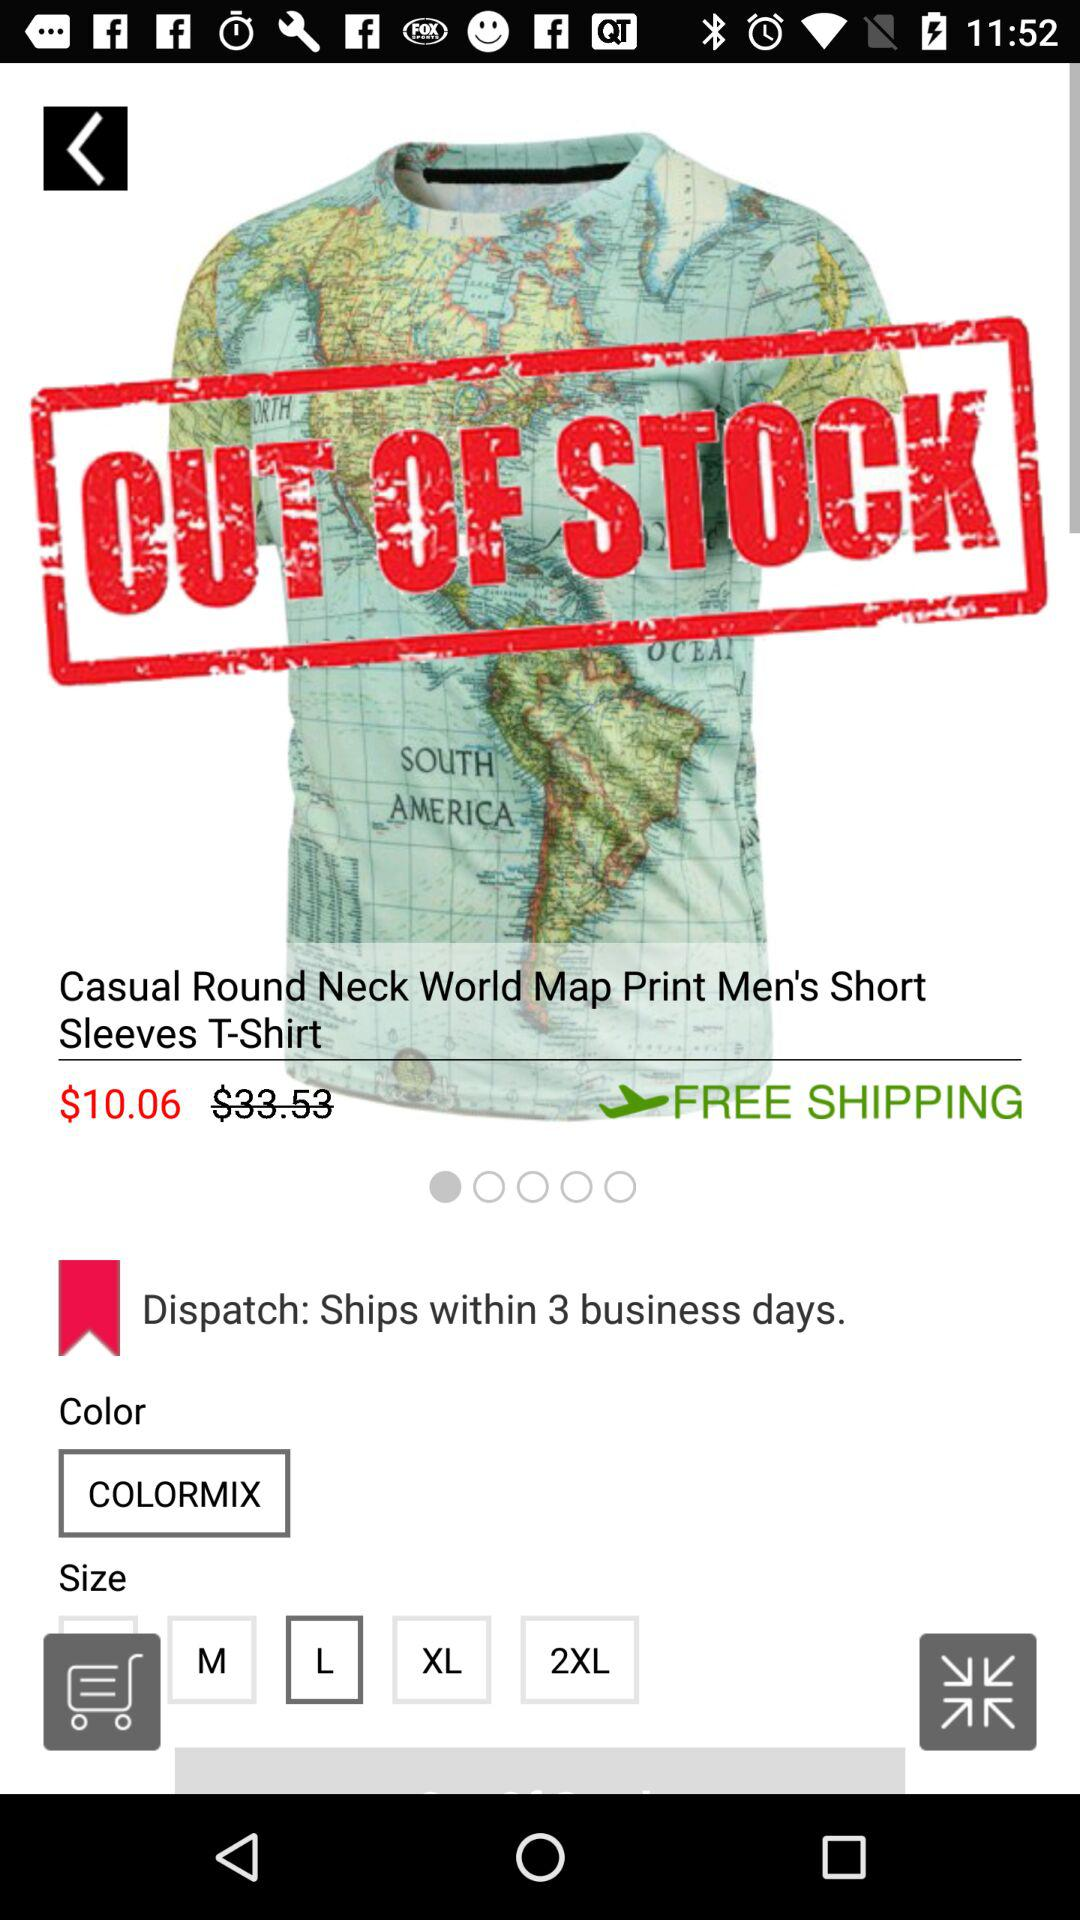How much is the shipping charge? The shipping charge is free. 